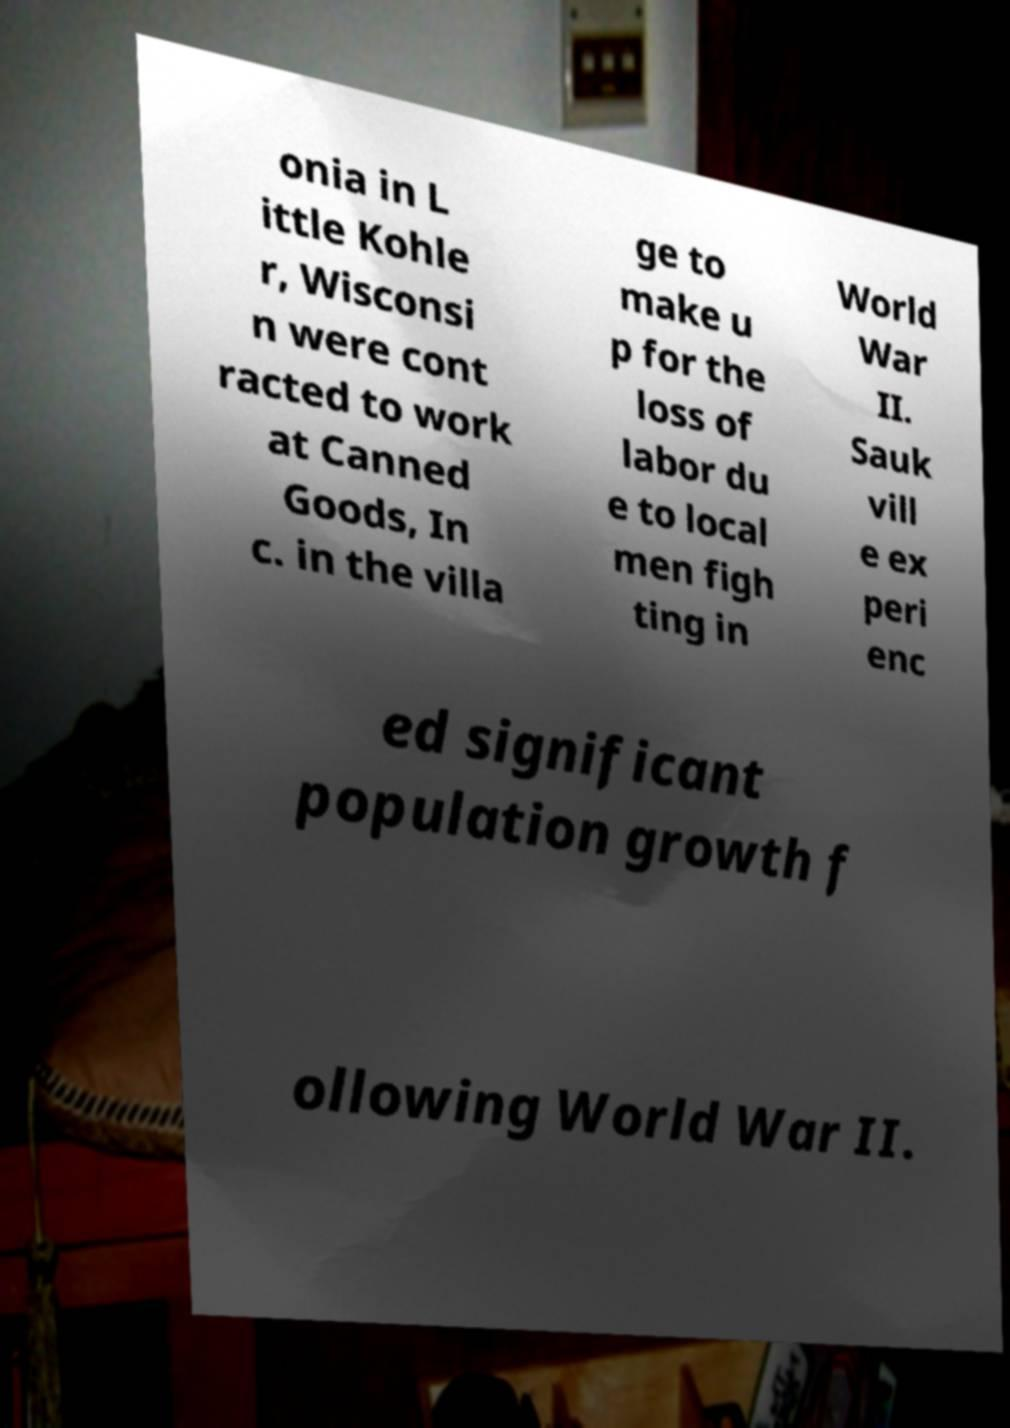There's text embedded in this image that I need extracted. Can you transcribe it verbatim? onia in L ittle Kohle r, Wisconsi n were cont racted to work at Canned Goods, In c. in the villa ge to make u p for the loss of labor du e to local men figh ting in World War II. Sauk vill e ex peri enc ed significant population growth f ollowing World War II. 